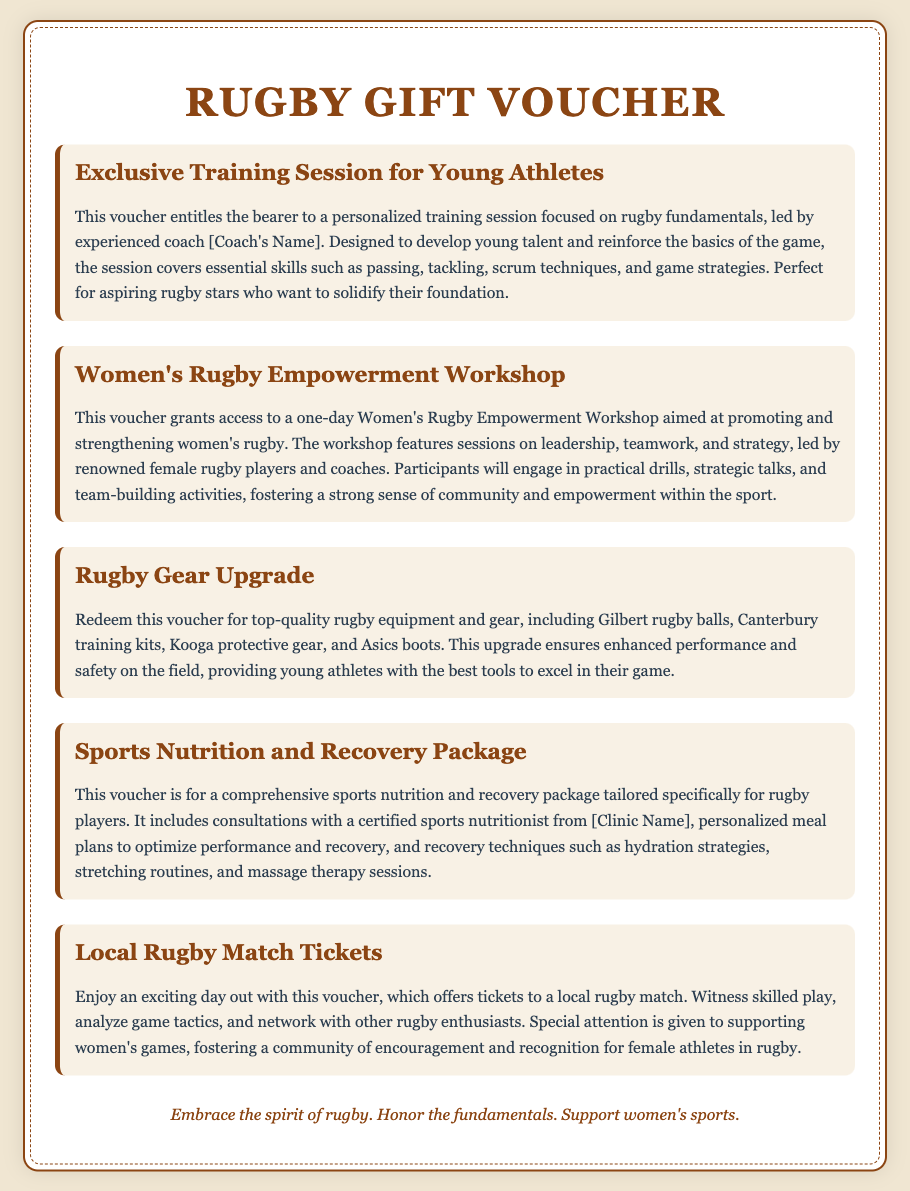What is the title of the voucher? The title of the voucher is prominently displayed at the top of the document, indicating its purpose.
Answer: Rugby Gift Voucher Who leads the training session for young athletes? The document specifies that an experienced coach will lead the training session, but does not give a specific name.
Answer: Experienced coach What type of workshop does the voucher provide access to? The document clearly mentions that the voucher grants access to a specific type of workshop focused on women's rugby.
Answer: Women's Rugby Empowerment Workshop What items are included in the Rugby Gear Upgrade? The document outlines specific brands and types of equipment provided with the gear upgrade.
Answer: Gilbert rugby balls, Canterbury training kits, Kooga protective gear, Asics boots What type of professional consultation is offered in the Sports Nutrition and Recovery Package? The document indicates that there is a specific type of professional whose services are included in the package.
Answer: Sports nutritionist What is emphasized in the Women's Rugby Empowerment Workshop? The document describes the focus of the workshop, which highlights specific skills to be developed.
Answer: Leadership, teamwork, and strategy What is a key benefit of attending the local rugby match? The document notes the opportunity attendees have when participating in this event.
Answer: Witness skilled play Which aspect is specifically supported in the local rugby match tickets? The document mentions a particular focus within the local rugby match offerings.
Answer: Supporting women's games What is the main purpose of the Exclusive Training Session for Young Athletes? The document explains the session's intent, highlighting a specific development focus.
Answer: Develop young talent and reinforce the basics of the game 